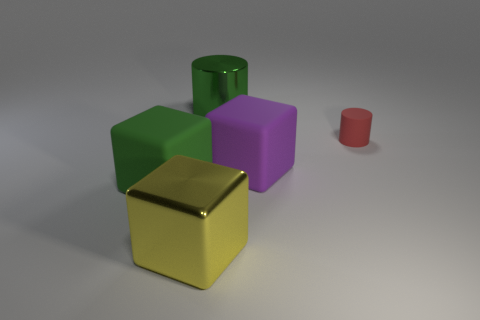Subtract all yellow metal cubes. How many cubes are left? 2 Add 1 small gray cylinders. How many objects exist? 6 Subtract all green cylinders. How many cylinders are left? 1 Add 3 metal objects. How many metal objects exist? 5 Subtract 0 brown balls. How many objects are left? 5 Subtract all cubes. How many objects are left? 2 Subtract 2 cylinders. How many cylinders are left? 0 Subtract all cyan blocks. Subtract all red spheres. How many blocks are left? 3 Subtract all blue blocks. How many gray cylinders are left? 0 Subtract all large cylinders. Subtract all big purple rubber objects. How many objects are left? 3 